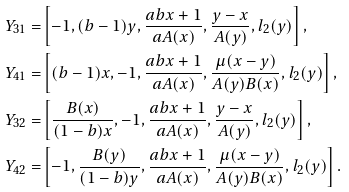Convert formula to latex. <formula><loc_0><loc_0><loc_500><loc_500>Y _ { 3 1 } = & \left [ - 1 , ( b - 1 ) y , \frac { a b x + 1 } { a A ( x ) } , \frac { y - x } { A ( y ) } , l _ { 2 } ( y ) \right ] , \\ Y _ { 4 1 } = & \left [ ( b - 1 ) x , - 1 , \frac { a b x + 1 } { a A ( x ) } , \frac { \mu ( x - y ) } { A ( y ) B ( x ) } , l _ { 2 } ( y ) \right ] , \\ Y _ { 3 2 } = & \left [ \frac { B ( x ) } { ( 1 - b ) x } , - 1 , \frac { a b x + 1 } { a A ( x ) } , \frac { y - x } { A ( y ) } , l _ { 2 } ( y ) \right ] , \\ Y _ { 4 2 } = & \left [ - 1 , \frac { B ( y ) } { ( 1 - b ) y } , \frac { a b x + 1 } { a A ( x ) } , \frac { \mu ( x - y ) } { A ( y ) B ( x ) } , l _ { 2 } ( y ) \right ] .</formula> 